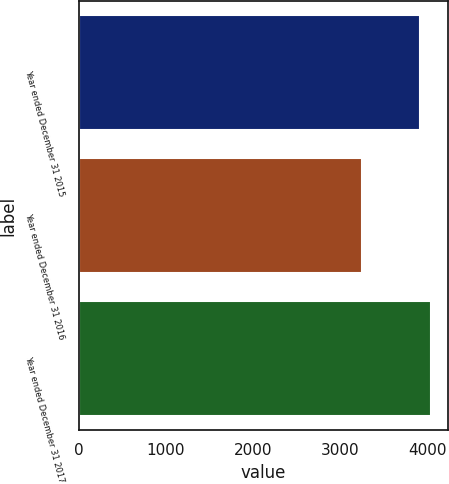Convert chart to OTSL. <chart><loc_0><loc_0><loc_500><loc_500><bar_chart><fcel>Year ended December 31 2015<fcel>Year ended December 31 2016<fcel>Year ended December 31 2017<nl><fcel>3913<fcel>3257<fcel>4039<nl></chart> 